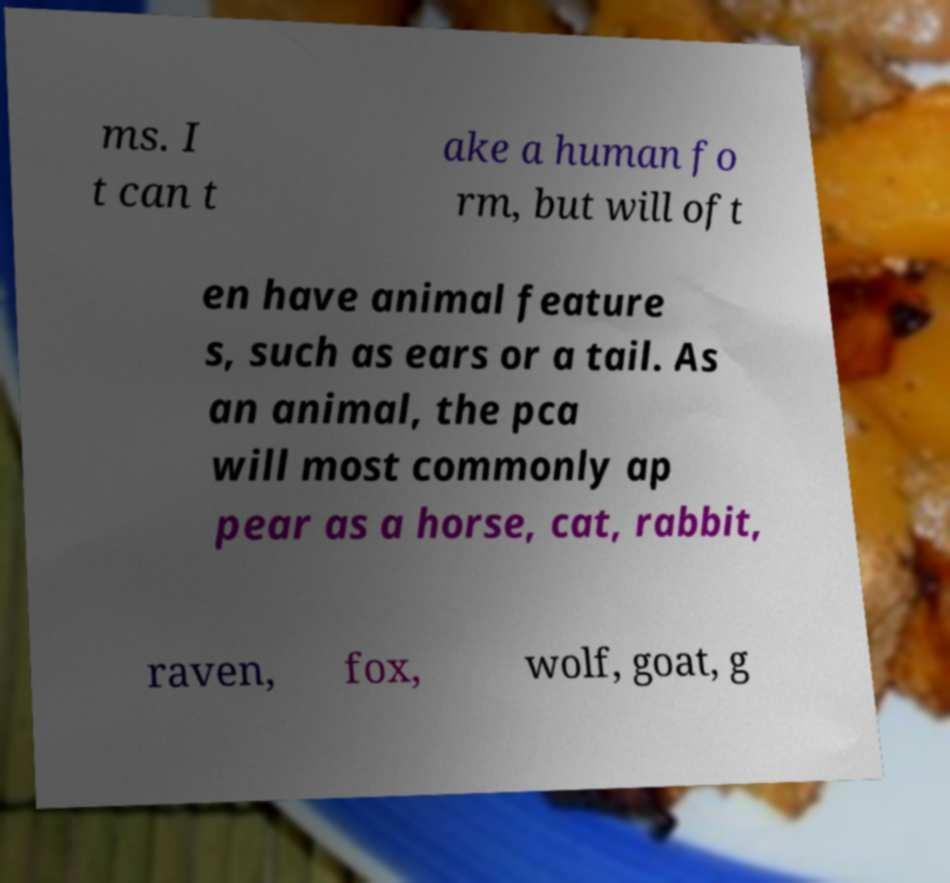Could you assist in decoding the text presented in this image and type it out clearly? ms. I t can t ake a human fo rm, but will oft en have animal feature s, such as ears or a tail. As an animal, the pca will most commonly ap pear as a horse, cat, rabbit, raven, fox, wolf, goat, g 